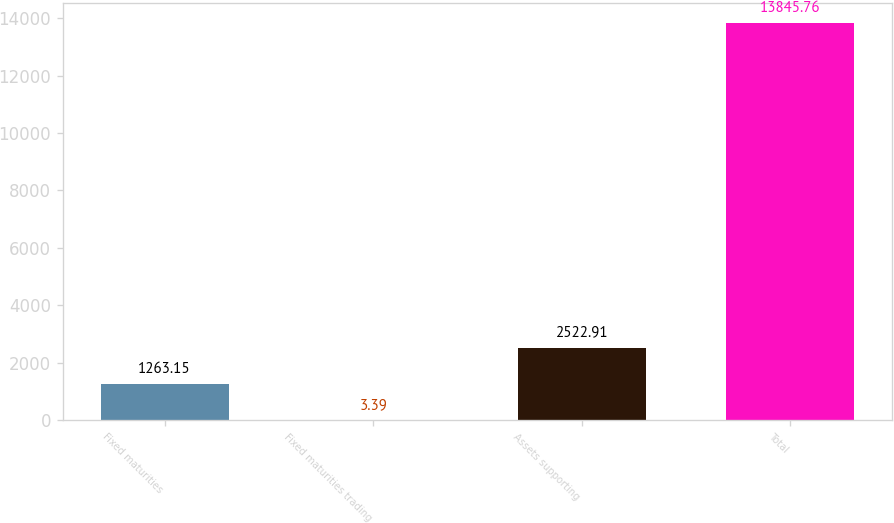Convert chart. <chart><loc_0><loc_0><loc_500><loc_500><bar_chart><fcel>Fixed maturities<fcel>Fixed maturities trading<fcel>Assets supporting<fcel>Total<nl><fcel>1263.15<fcel>3.39<fcel>2522.91<fcel>13845.8<nl></chart> 